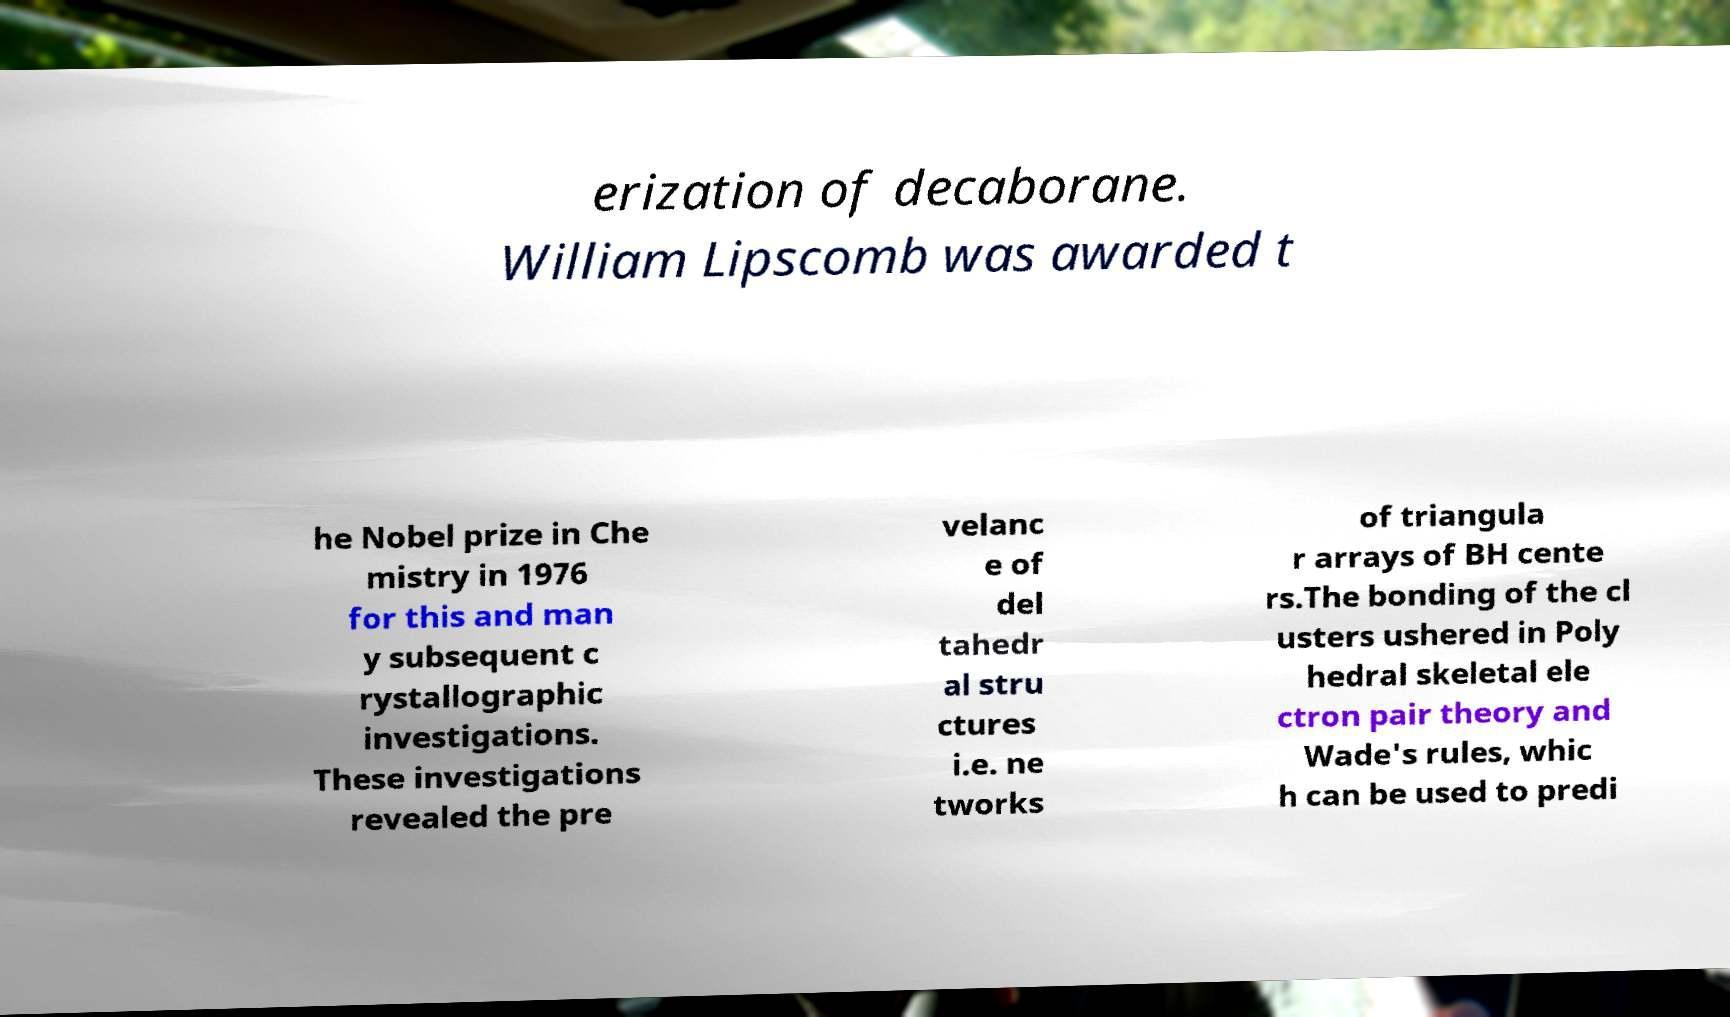Could you assist in decoding the text presented in this image and type it out clearly? erization of decaborane. William Lipscomb was awarded t he Nobel prize in Che mistry in 1976 for this and man y subsequent c rystallographic investigations. These investigations revealed the pre velanc e of del tahedr al stru ctures i.e. ne tworks of triangula r arrays of BH cente rs.The bonding of the cl usters ushered in Poly hedral skeletal ele ctron pair theory and Wade's rules, whic h can be used to predi 